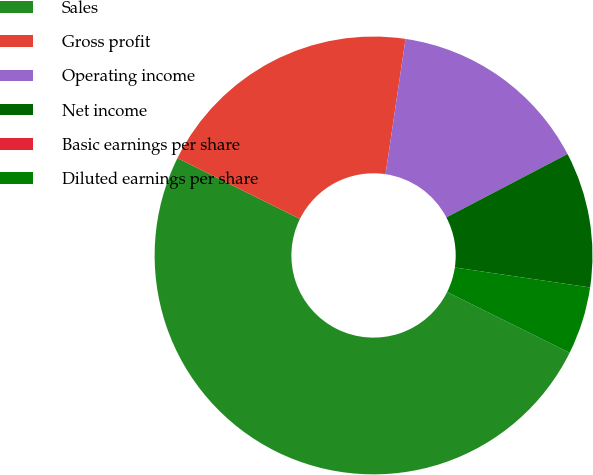<chart> <loc_0><loc_0><loc_500><loc_500><pie_chart><fcel>Sales<fcel>Gross profit<fcel>Operating income<fcel>Net income<fcel>Basic earnings per share<fcel>Diluted earnings per share<nl><fcel>50.0%<fcel>20.0%<fcel>15.0%<fcel>10.0%<fcel>0.0%<fcel>5.0%<nl></chart> 